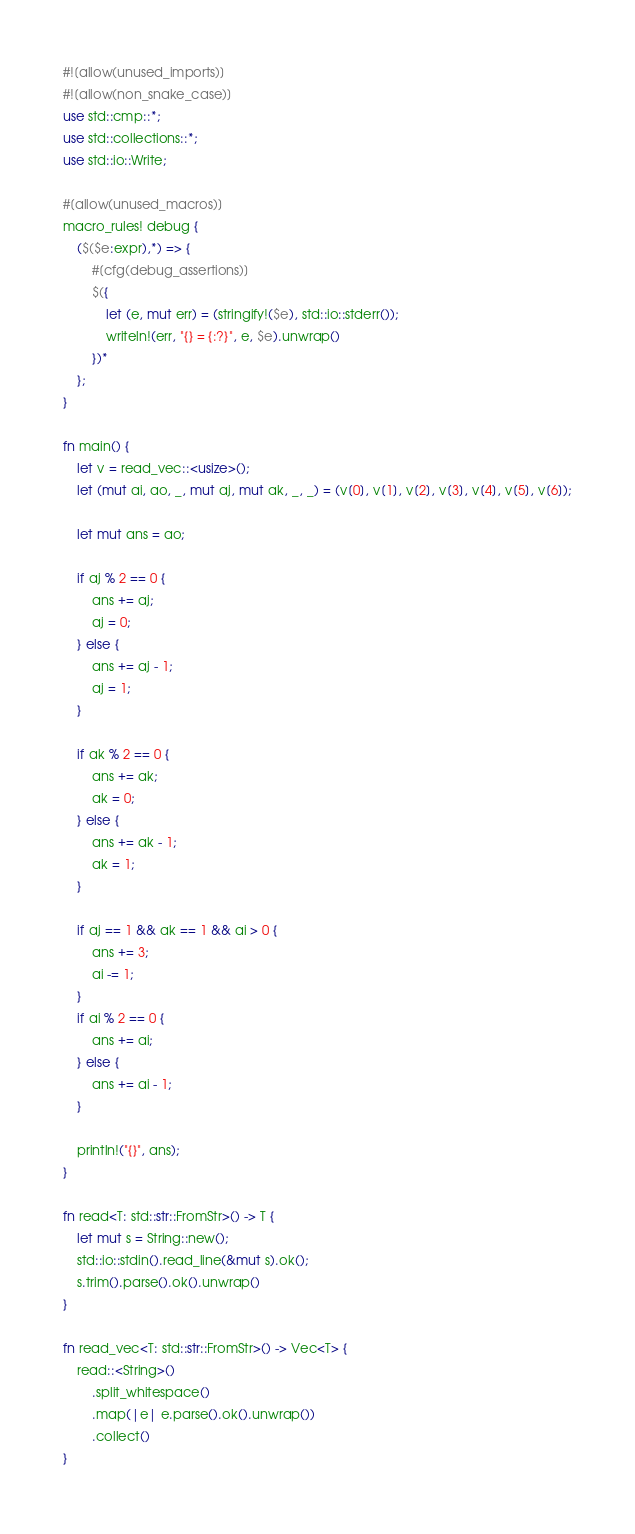<code> <loc_0><loc_0><loc_500><loc_500><_Rust_>#![allow(unused_imports)]
#![allow(non_snake_case)]
use std::cmp::*;
use std::collections::*;
use std::io::Write;

#[allow(unused_macros)]
macro_rules! debug {
    ($($e:expr),*) => {
        #[cfg(debug_assertions)]
        $({
            let (e, mut err) = (stringify!($e), std::io::stderr());
            writeln!(err, "{} = {:?}", e, $e).unwrap()
        })*
    };
}

fn main() {
    let v = read_vec::<usize>();
    let (mut ai, ao, _, mut aj, mut ak, _, _) = (v[0], v[1], v[2], v[3], v[4], v[5], v[6]);

    let mut ans = ao;

    if aj % 2 == 0 {
        ans += aj;
        aj = 0;
    } else {
        ans += aj - 1;
        aj = 1;
    }

    if ak % 2 == 0 {
        ans += ak;
        ak = 0;
    } else {
        ans += ak - 1;
        ak = 1;
    }

    if aj == 1 && ak == 1 && ai > 0 {
        ans += 3;
        ai -= 1;
    }
    if ai % 2 == 0 {
        ans += ai;
    } else {
        ans += ai - 1;
    }

    println!("{}", ans);
}

fn read<T: std::str::FromStr>() -> T {
    let mut s = String::new();
    std::io::stdin().read_line(&mut s).ok();
    s.trim().parse().ok().unwrap()
}

fn read_vec<T: std::str::FromStr>() -> Vec<T> {
    read::<String>()
        .split_whitespace()
        .map(|e| e.parse().ok().unwrap())
        .collect()
}
</code> 